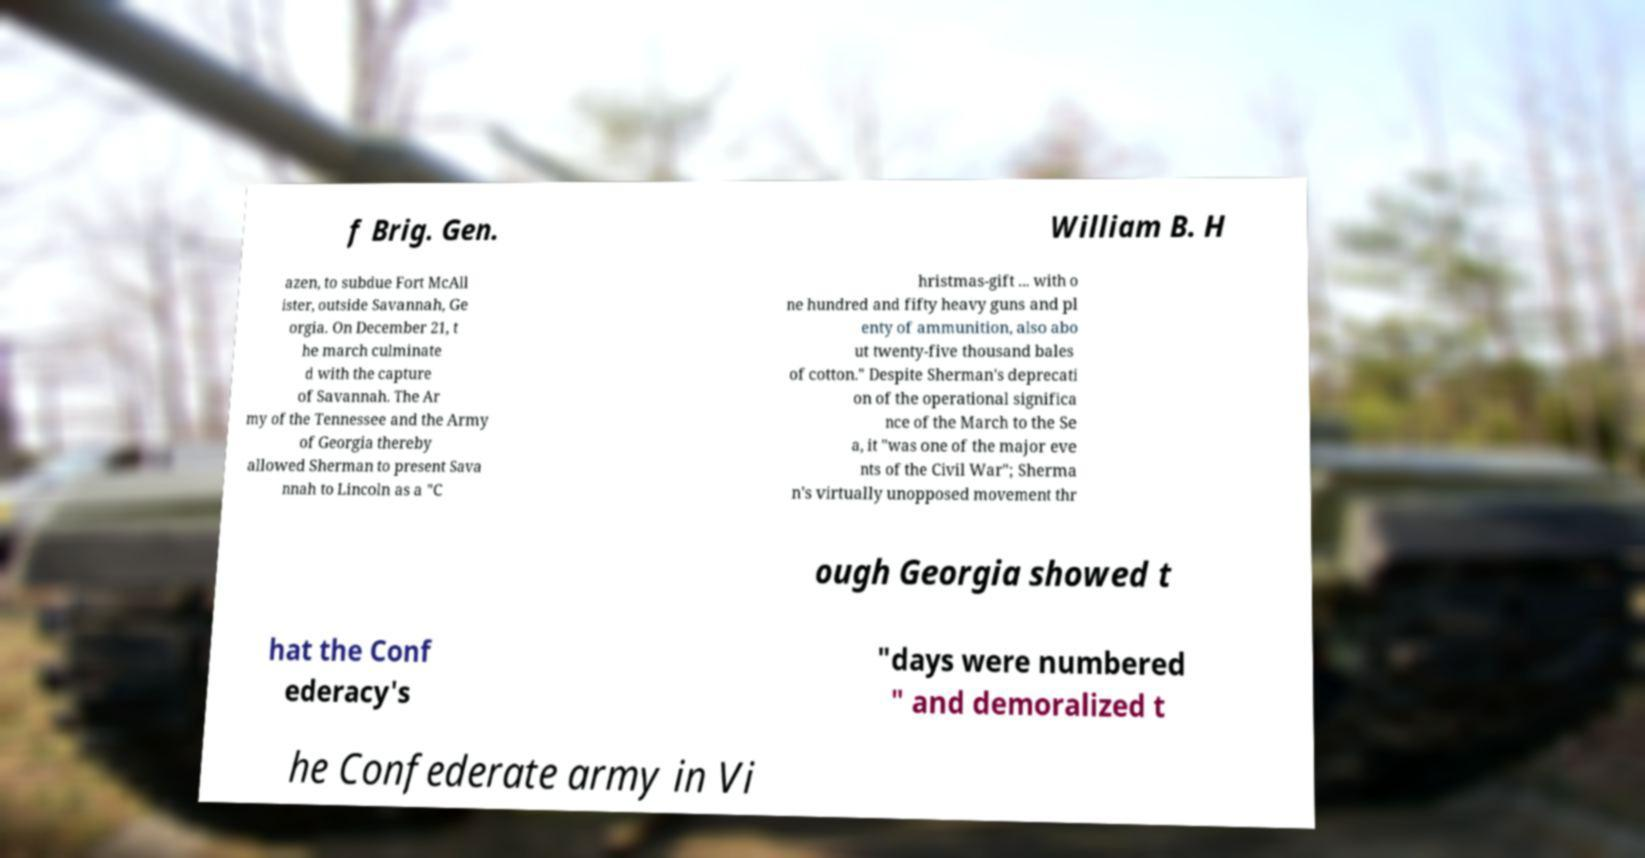Could you extract and type out the text from this image? f Brig. Gen. William B. H azen, to subdue Fort McAll ister, outside Savannah, Ge orgia. On December 21, t he march culminate d with the capture of Savannah. The Ar my of the Tennessee and the Army of Georgia thereby allowed Sherman to present Sava nnah to Lincoln as a "C hristmas-gift ... with o ne hundred and fifty heavy guns and pl enty of ammunition, also abo ut twenty-five thousand bales of cotton." Despite Sherman's deprecati on of the operational significa nce of the March to the Se a, it "was one of the major eve nts of the Civil War"; Sherma n's virtually unopposed movement thr ough Georgia showed t hat the Conf ederacy's "days were numbered " and demoralized t he Confederate army in Vi 